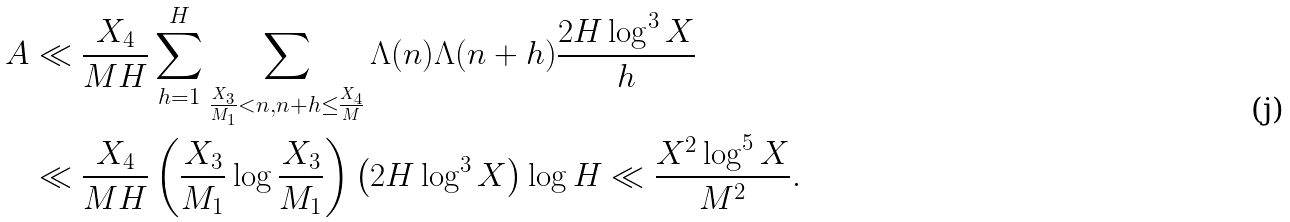Convert formula to latex. <formula><loc_0><loc_0><loc_500><loc_500>A & \ll \frac { X _ { 4 } } { M H } \sum _ { h = 1 } ^ { H } \sum _ { \frac { X _ { 3 } } { M _ { 1 } } < n , n + h \leq \frac { X _ { 4 } } { M } } \Lambda ( n ) \Lambda ( n + h ) \frac { 2 H \log ^ { 3 } X } { h } \\ & \ll \frac { X _ { 4 } } { M H } \left ( \frac { X _ { 3 } } { M _ { 1 } } \log \frac { X _ { 3 } } { M _ { 1 } } \right ) \left ( 2 H \log ^ { 3 } X \right ) \log H \ll \frac { X ^ { 2 } \log ^ { 5 } X } { M ^ { 2 } } .</formula> 